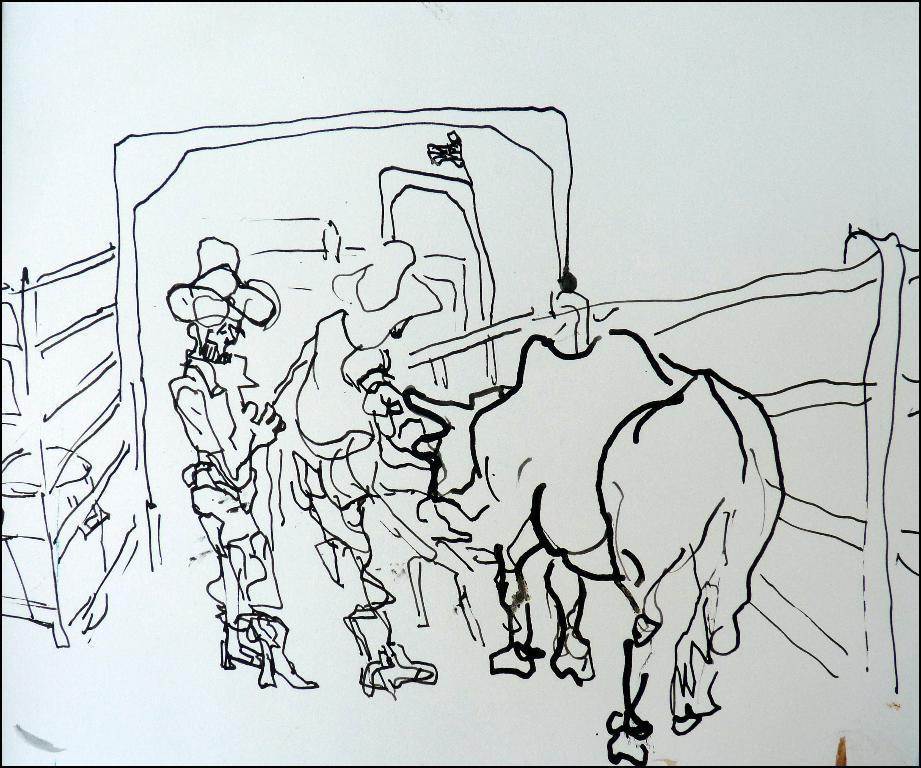Could you give a brief overview of what you see in this image? In this picture I can observe a sketch. The sketch is drawn with black color. I can observe an animal and a person in this picture. The background is in white color. 